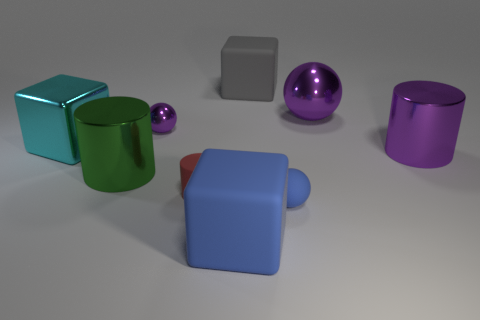There is a cylinder that is the same color as the large shiny sphere; what size is it?
Your answer should be very brief. Large. How many metal cylinders have the same size as the cyan shiny cube?
Offer a very short reply. 2. Are there an equal number of blocks behind the small purple metallic sphere and big gray blocks?
Your answer should be very brief. Yes. What number of matte things are behind the large purple metal ball and in front of the big purple ball?
Keep it short and to the point. 0. There is another purple sphere that is the same material as the big sphere; what is its size?
Ensure brevity in your answer.  Small. How many cyan things have the same shape as the red rubber thing?
Make the answer very short. 0. Are there more large purple spheres that are right of the large shiny sphere than cylinders?
Give a very brief answer. No. There is a object that is on the right side of the cyan metallic object and on the left side of the tiny purple metal thing; what shape is it?
Provide a succinct answer. Cylinder. Do the green metal thing and the red rubber thing have the same size?
Provide a succinct answer. No. What number of big green things are in front of the tiny blue thing?
Provide a short and direct response. 0. 